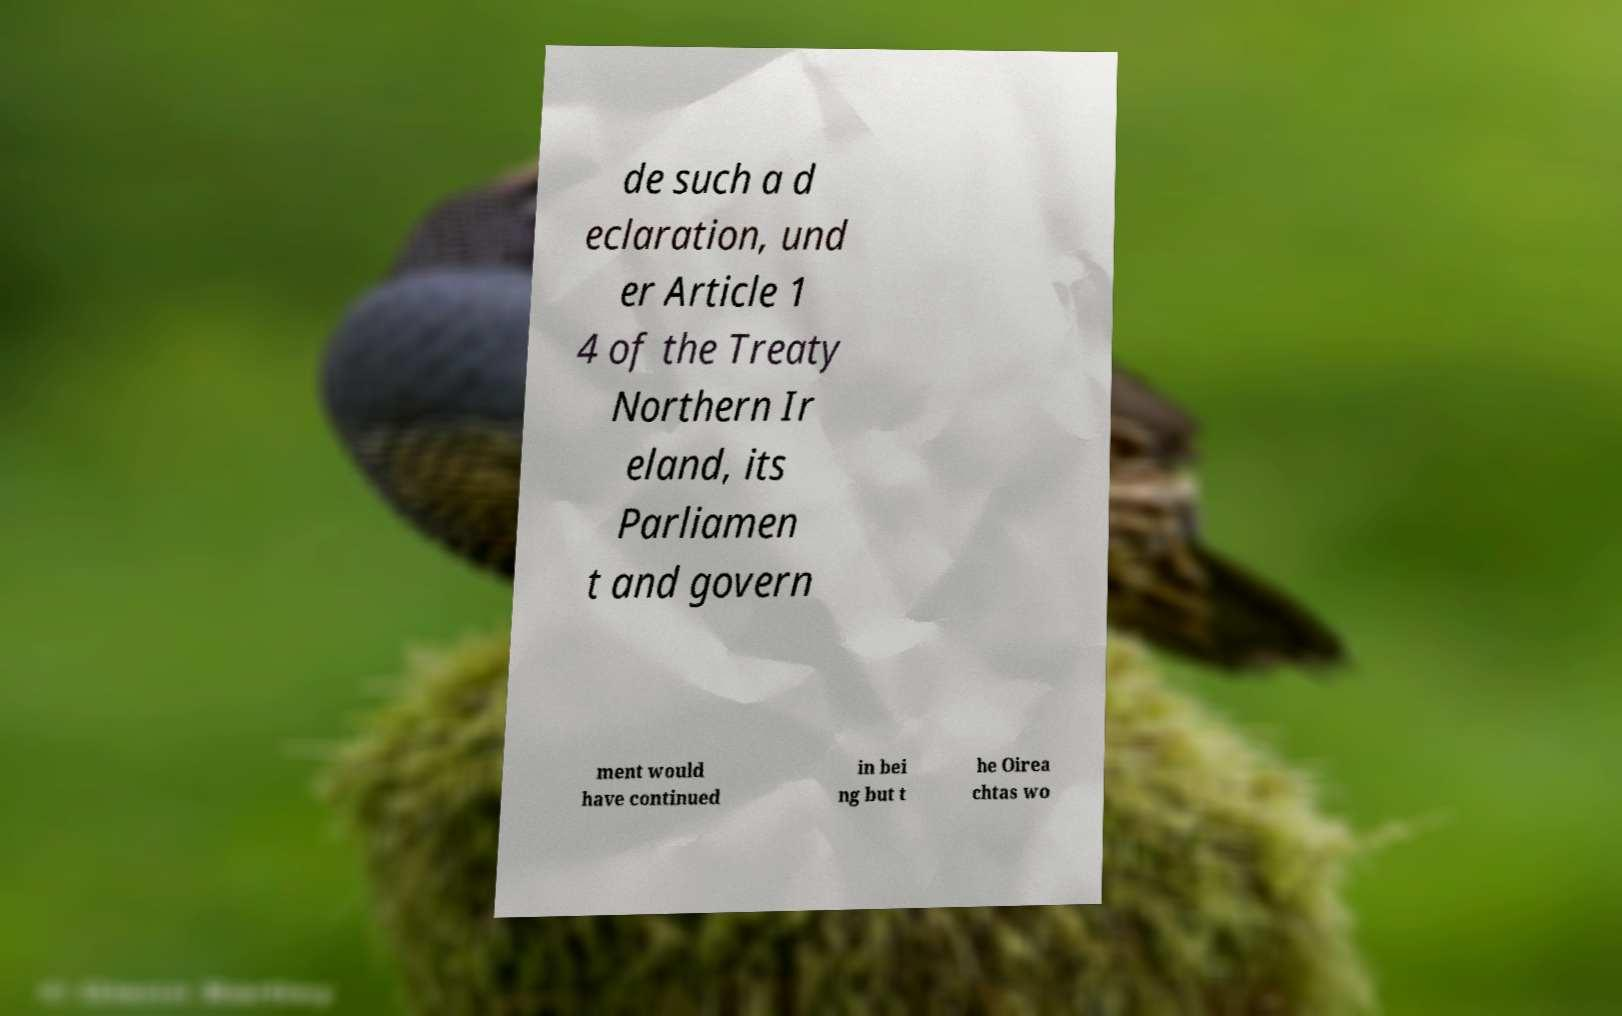I need the written content from this picture converted into text. Can you do that? de such a d eclaration, und er Article 1 4 of the Treaty Northern Ir eland, its Parliamen t and govern ment would have continued in bei ng but t he Oirea chtas wo 